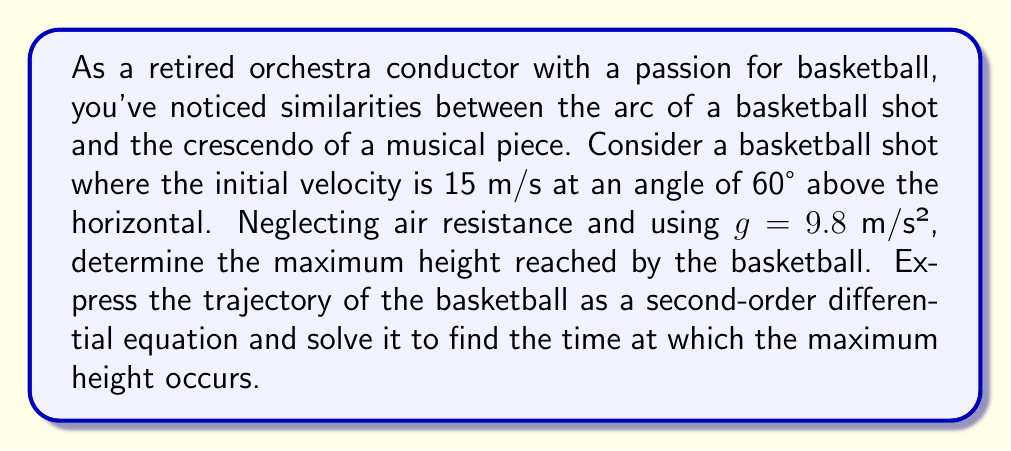Could you help me with this problem? Let's approach this step-by-step:

1) First, we need to set up our coordinate system. Let's use x for horizontal distance and y for vertical distance, with the origin at the point of release.

2) The second-order differential equation for the vertical motion of the basketball is:

   $$\frac{d^2y}{dt^2} = -g$$

   where g is the acceleration due to gravity (9.8 m/s²).

3) We can solve this equation by integrating twice. First integration gives us the velocity:

   $$\frac{dy}{dt} = -gt + C_1$$

   where $C_1$ is a constant of integration.

4) The initial vertical velocity is $v_0\sin\theta$, where $v_0$ is the initial velocity and $\theta$ is the angle. So:

   $$v_0\sin\theta = 15 \cdot \sin(60°) = 15 \cdot \frac{\sqrt{3}}{2} = 7.5\sqrt{3}$$

5) Using this initial condition, we can find $C_1$:

   $$7.5\sqrt{3} = C_1$$

6) Now our velocity equation is:

   $$\frac{dy}{dt} = -9.8t + 7.5\sqrt{3}$$

7) Integrating again gives us the position:

   $$y = -4.9t^2 + 7.5\sqrt{3}t + C_2$$

8) At t = 0, y = 0, so $C_2 = 0$.

9) To find the maximum height, we need to find when the vertical velocity is zero:

   $$0 = -9.8t + 7.5\sqrt{3}$$
   $$t = \frac{7.5\sqrt{3}}{9.8} \approx 1.32 \text{ seconds}$$

10) The maximum height occurs at this time. Plugging this back into our position equation:

    $$y_{\text{max}} = -4.9(1.32)^2 + 7.5\sqrt{3}(1.32)$$
    $$y_{\text{max}} = -8.55 + 16.5 = 7.95 \text{ meters}$$

Thus, the maximum height reached by the basketball is approximately 7.95 meters, and this occurs at about 1.32 seconds after the shot is taken.
Answer: Maximum height: 7.95 meters
Time to reach maximum height: 1.32 seconds 